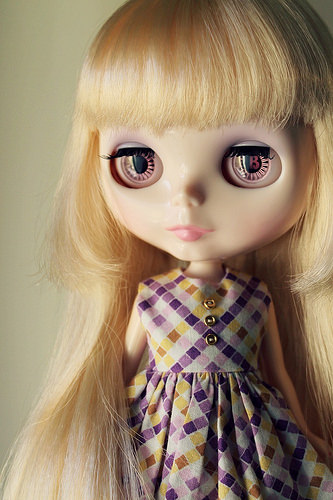<image>
Is there a doll eye in front of the dress? No. The doll eye is not in front of the dress. The spatial positioning shows a different relationship between these objects. 